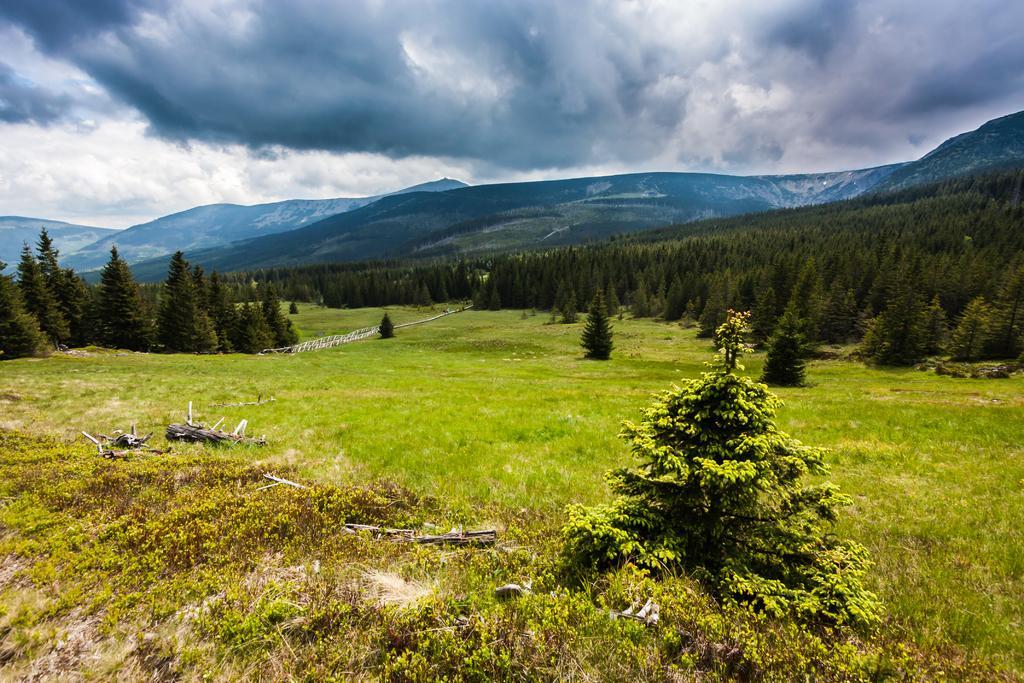Please provide a concise description of this image. In this image, we can see some grass, plants, trees, mountains. We can see the ground with some objects. We can also see the sky with clouds. 